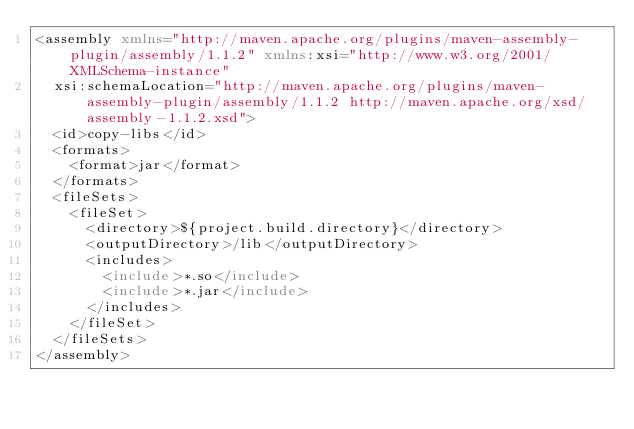<code> <loc_0><loc_0><loc_500><loc_500><_XML_><assembly xmlns="http://maven.apache.org/plugins/maven-assembly-plugin/assembly/1.1.2" xmlns:xsi="http://www.w3.org/2001/XMLSchema-instance"
  xsi:schemaLocation="http://maven.apache.org/plugins/maven-assembly-plugin/assembly/1.1.2 http://maven.apache.org/xsd/assembly-1.1.2.xsd">
  <id>copy-libs</id>
  <formats>
    <format>jar</format>
  </formats>
  <fileSets>
    <fileSet>
      <directory>${project.build.directory}</directory>
      <outputDirectory>/lib</outputDirectory>
      <includes>
        <include>*.so</include>
        <include>*.jar</include>
      </includes>
    </fileSet>
  </fileSets>
</assembly></code> 